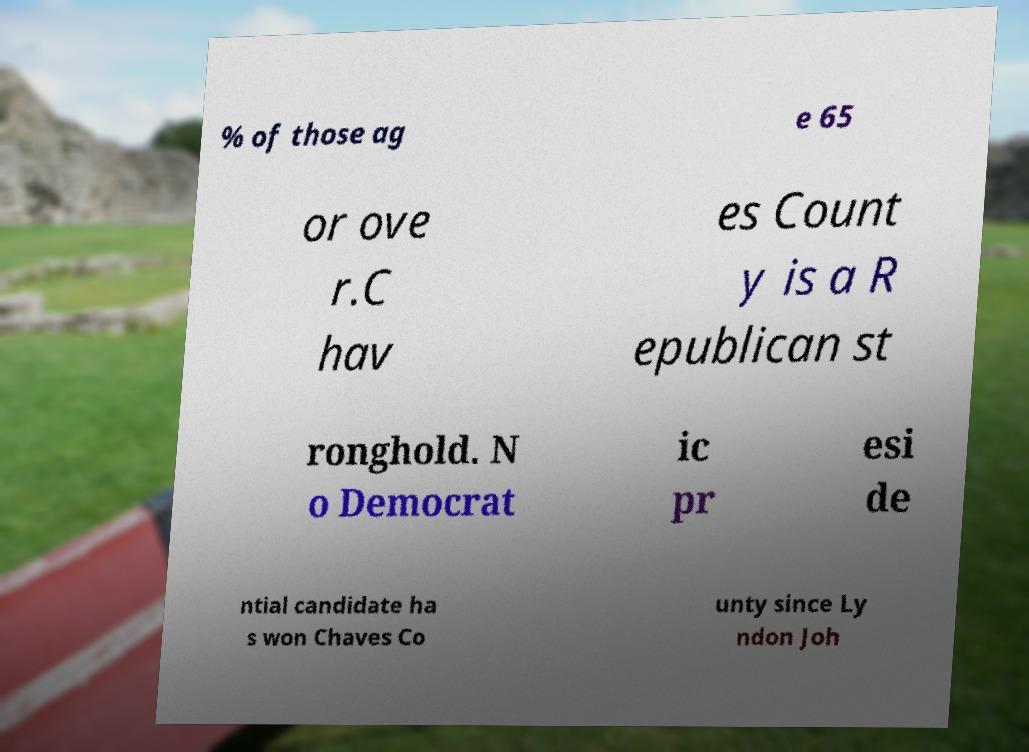Can you accurately transcribe the text from the provided image for me? % of those ag e 65 or ove r.C hav es Count y is a R epublican st ronghold. N o Democrat ic pr esi de ntial candidate ha s won Chaves Co unty since Ly ndon Joh 